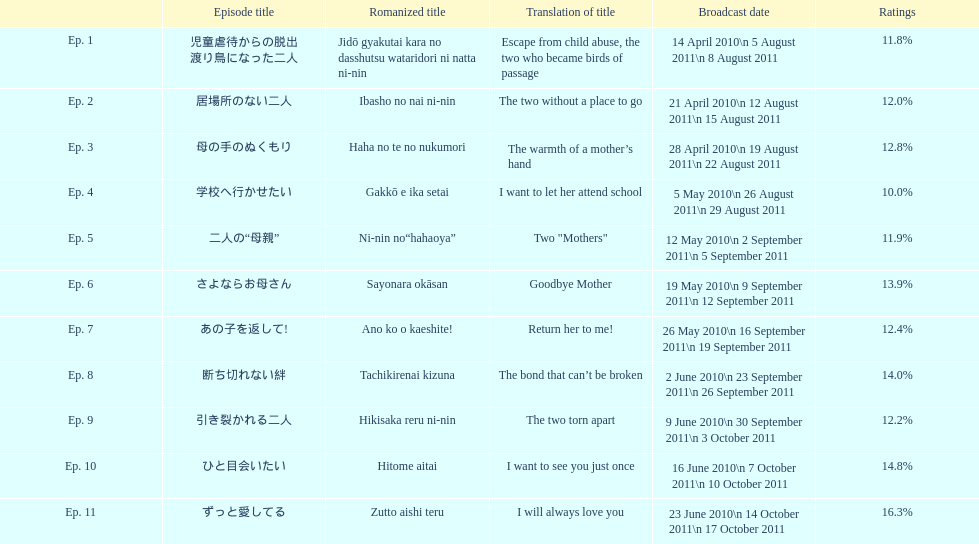Can you give me this table as a dict? {'header': ['', 'Episode title', 'Romanized title', 'Translation of title', 'Broadcast date', 'Ratings'], 'rows': [['Ep. 1', '児童虐待からの脱出 渡り鳥になった二人', 'Jidō gyakutai kara no dasshutsu wataridori ni natta ni-nin', 'Escape from child abuse, the two who became birds of passage', '14 April 2010\\n 5 August 2011\\n 8 August 2011', '11.8%'], ['Ep. 2', '居場所のない二人', 'Ibasho no nai ni-nin', 'The two without a place to go', '21 April 2010\\n 12 August 2011\\n 15 August 2011', '12.0%'], ['Ep. 3', '母の手のぬくもり', 'Haha no te no nukumori', 'The warmth of a mother’s hand', '28 April 2010\\n 19 August 2011\\n 22 August 2011', '12.8%'], ['Ep. 4', '学校へ行かせたい', 'Gakkō e ika setai', 'I want to let her attend school', '5 May 2010\\n 26 August 2011\\n 29 August 2011', '10.0%'], ['Ep. 5', '二人の“母親”', 'Ni-nin no“hahaoya”', 'Two "Mothers"', '12 May 2010\\n 2 September 2011\\n 5 September 2011', '11.9%'], ['Ep. 6', 'さよならお母さん', 'Sayonara okāsan', 'Goodbye Mother', '19 May 2010\\n 9 September 2011\\n 12 September 2011', '13.9%'], ['Ep. 7', 'あの子を返して!', 'Ano ko o kaeshite!', 'Return her to me!', '26 May 2010\\n 16 September 2011\\n 19 September 2011', '12.4%'], ['Ep. 8', '断ち切れない絆', 'Tachikirenai kizuna', 'The bond that can’t be broken', '2 June 2010\\n 23 September 2011\\n 26 September 2011', '14.0%'], ['Ep. 9', '引き裂かれる二人', 'Hikisaka reru ni-nin', 'The two torn apart', '9 June 2010\\n 30 September 2011\\n 3 October 2011', '12.2%'], ['Ep. 10', 'ひと目会いたい', 'Hitome aitai', 'I want to see you just once', '16 June 2010\\n 7 October 2011\\n 10 October 2011', '14.8%'], ['Ep. 11', 'ずっと愛してる', 'Zutto aishi teru', 'I will always love you', '23 June 2010\\n 14 October 2011\\n 17 October 2011', '16.3%']]} How many episodes were shown in japan during april 2010? 3. 